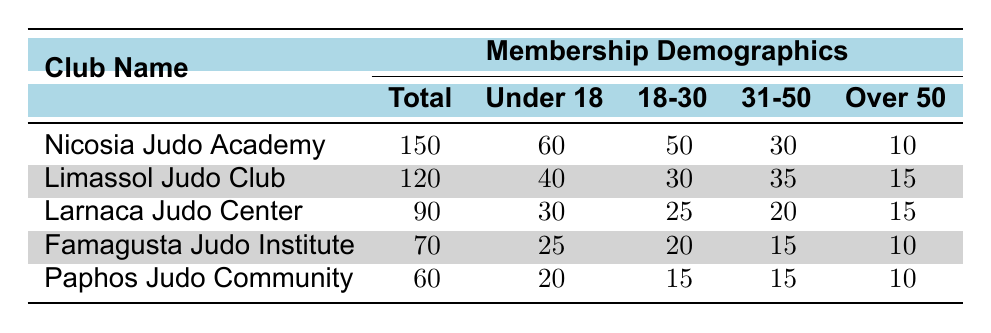What's the total membership of the Nicosia Judo Academy? The table indicates that the Nicosia Judo Academy has a total of 150 members.
Answer: 150 How many members are aged 31 to 50 in the Limassol Judo Club? According to the table, the Limassol Judo Club has 35 members aged 31 to 50.
Answer: 35 Which judo club has the highest number of members under 18? The Nicosia Judo Academy has 60 members under 18, which is more than any other club listed.
Answer: Nicosia Judo Academy What is the total number of females across all judo clubs? The total number of females is calculated as follows: 60 (Nicosia) + 50 (Limassol) + 40 (Larnaca) + 30 (Famagusta) + 30 (Paphos) = 210.
Answer: 210 Are there more total male members than female members in the Paphos Judo Community? Paphos Judo Community has 30 male members and 30 female members, making the totals equal.
Answer: No What is the average number of members in all judo clubs? To find the average, sum the total memberships: 150 + 120 + 90 + 70 + 60 = 490, then divide by 5 clubs: 490/5 = 98.
Answer: 98 Which age group has the least representation in the Famagusta Judo Institute? Famagusta Judo Institute has 10 members who are over 50, which is the lowest number among all age groups listed for this club.
Answer: Over 50 What percentage of the total membership from Larnaca Judo Center is under 18? For Larnaca, the percentage is calculated as (30 under 18 / 90 total members) * 100 = 33.33%.
Answer: 33.33% How does the total membership of Nicosia Judo Academy compare to the combined total of Paphos and Famagusta Judo clubs? Nicosia has 150 members while Paphos (60) and Famagusta (70) combined have 130 members, meaning Nicosia has more members.
Answer: Nicosia has more members Which judo club was founded the most recently? Paphos Judo Community was founded in 2020, making it the most recent club in the table.
Answer: Paphos Judo Community 